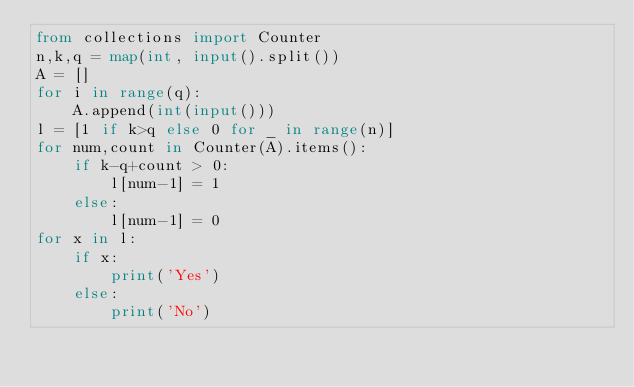Convert code to text. <code><loc_0><loc_0><loc_500><loc_500><_Python_>from collections import Counter
n,k,q = map(int, input().split())
A = []
for i in range(q):
    A.append(int(input()))
l = [1 if k>q else 0 for _ in range(n)]
for num,count in Counter(A).items():
    if k-q+count > 0:
        l[num-1] = 1
    else:
        l[num-1] = 0
for x in l:
    if x:
        print('Yes')
    else:
        print('No')</code> 